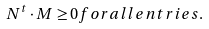Convert formula to latex. <formula><loc_0><loc_0><loc_500><loc_500>N ^ { t } \cdot M \geq 0 f o r a l l e n t r i e s .</formula> 